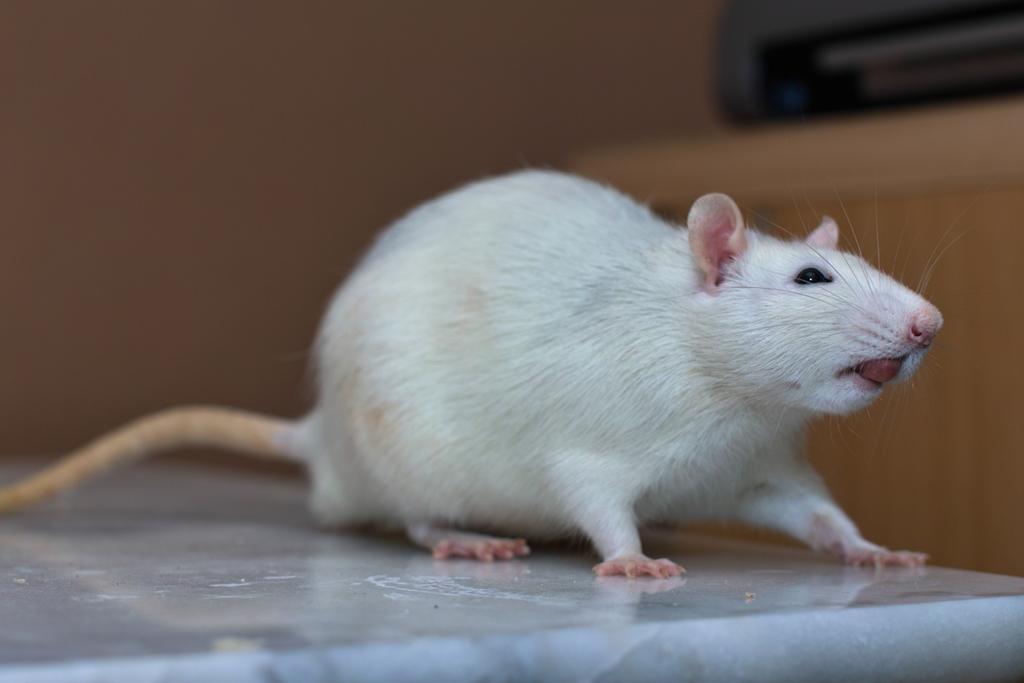Can you describe this image briefly? In this image we can see rat which is on the marble floor. And the background is brown and blur. 